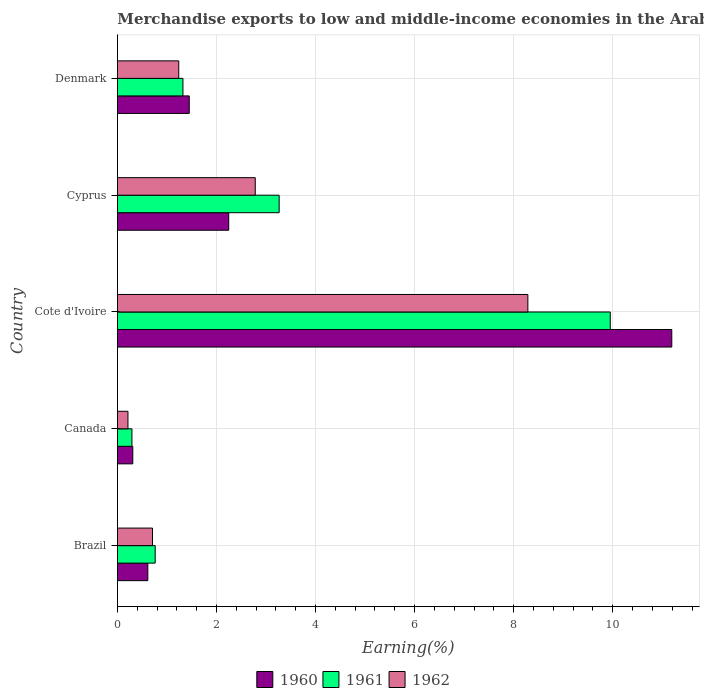How many groups of bars are there?
Give a very brief answer. 5. How many bars are there on the 3rd tick from the top?
Your response must be concise. 3. In how many cases, is the number of bars for a given country not equal to the number of legend labels?
Your response must be concise. 0. What is the percentage of amount earned from merchandise exports in 1960 in Canada?
Offer a very short reply. 0.31. Across all countries, what is the maximum percentage of amount earned from merchandise exports in 1962?
Give a very brief answer. 8.29. Across all countries, what is the minimum percentage of amount earned from merchandise exports in 1960?
Offer a very short reply. 0.31. In which country was the percentage of amount earned from merchandise exports in 1961 maximum?
Make the answer very short. Cote d'Ivoire. In which country was the percentage of amount earned from merchandise exports in 1962 minimum?
Provide a succinct answer. Canada. What is the total percentage of amount earned from merchandise exports in 1960 in the graph?
Keep it short and to the point. 15.81. What is the difference between the percentage of amount earned from merchandise exports in 1960 in Cote d'Ivoire and that in Cyprus?
Your answer should be compact. 8.94. What is the difference between the percentage of amount earned from merchandise exports in 1960 in Denmark and the percentage of amount earned from merchandise exports in 1961 in Canada?
Make the answer very short. 1.16. What is the average percentage of amount earned from merchandise exports in 1960 per country?
Offer a very short reply. 3.16. What is the difference between the percentage of amount earned from merchandise exports in 1961 and percentage of amount earned from merchandise exports in 1962 in Cyprus?
Provide a succinct answer. 0.48. In how many countries, is the percentage of amount earned from merchandise exports in 1962 greater than 6.8 %?
Provide a succinct answer. 1. What is the ratio of the percentage of amount earned from merchandise exports in 1962 in Cote d'Ivoire to that in Cyprus?
Your response must be concise. 2.98. Is the percentage of amount earned from merchandise exports in 1961 in Canada less than that in Denmark?
Ensure brevity in your answer.  Yes. What is the difference between the highest and the second highest percentage of amount earned from merchandise exports in 1960?
Give a very brief answer. 8.94. What is the difference between the highest and the lowest percentage of amount earned from merchandise exports in 1960?
Keep it short and to the point. 10.88. Is the sum of the percentage of amount earned from merchandise exports in 1962 in Canada and Cyprus greater than the maximum percentage of amount earned from merchandise exports in 1961 across all countries?
Your answer should be compact. No. What does the 3rd bar from the bottom in Brazil represents?
Make the answer very short. 1962. Is it the case that in every country, the sum of the percentage of amount earned from merchandise exports in 1962 and percentage of amount earned from merchandise exports in 1960 is greater than the percentage of amount earned from merchandise exports in 1961?
Keep it short and to the point. Yes. What is the difference between two consecutive major ticks on the X-axis?
Give a very brief answer. 2. What is the title of the graph?
Offer a terse response. Merchandise exports to low and middle-income economies in the Arab World. What is the label or title of the X-axis?
Keep it short and to the point. Earning(%). What is the Earning(%) of 1960 in Brazil?
Provide a succinct answer. 0.61. What is the Earning(%) of 1961 in Brazil?
Make the answer very short. 0.76. What is the Earning(%) of 1962 in Brazil?
Keep it short and to the point. 0.71. What is the Earning(%) in 1960 in Canada?
Provide a short and direct response. 0.31. What is the Earning(%) in 1961 in Canada?
Give a very brief answer. 0.29. What is the Earning(%) of 1962 in Canada?
Keep it short and to the point. 0.21. What is the Earning(%) in 1960 in Cote d'Ivoire?
Your response must be concise. 11.19. What is the Earning(%) of 1961 in Cote d'Ivoire?
Your answer should be compact. 9.95. What is the Earning(%) of 1962 in Cote d'Ivoire?
Give a very brief answer. 8.29. What is the Earning(%) in 1960 in Cyprus?
Your answer should be very brief. 2.25. What is the Earning(%) in 1961 in Cyprus?
Your response must be concise. 3.27. What is the Earning(%) of 1962 in Cyprus?
Keep it short and to the point. 2.78. What is the Earning(%) in 1960 in Denmark?
Give a very brief answer. 1.45. What is the Earning(%) of 1961 in Denmark?
Your answer should be compact. 1.32. What is the Earning(%) of 1962 in Denmark?
Provide a short and direct response. 1.24. Across all countries, what is the maximum Earning(%) of 1960?
Keep it short and to the point. 11.19. Across all countries, what is the maximum Earning(%) of 1961?
Your answer should be very brief. 9.95. Across all countries, what is the maximum Earning(%) in 1962?
Provide a short and direct response. 8.29. Across all countries, what is the minimum Earning(%) in 1960?
Provide a short and direct response. 0.31. Across all countries, what is the minimum Earning(%) of 1961?
Offer a terse response. 0.29. Across all countries, what is the minimum Earning(%) in 1962?
Your answer should be very brief. 0.21. What is the total Earning(%) in 1960 in the graph?
Provide a succinct answer. 15.81. What is the total Earning(%) in 1961 in the graph?
Your response must be concise. 15.59. What is the total Earning(%) of 1962 in the graph?
Offer a terse response. 13.23. What is the difference between the Earning(%) in 1960 in Brazil and that in Canada?
Your response must be concise. 0.3. What is the difference between the Earning(%) in 1961 in Brazil and that in Canada?
Ensure brevity in your answer.  0.47. What is the difference between the Earning(%) in 1962 in Brazil and that in Canada?
Offer a very short reply. 0.5. What is the difference between the Earning(%) of 1960 in Brazil and that in Cote d'Ivoire?
Your answer should be very brief. -10.58. What is the difference between the Earning(%) in 1961 in Brazil and that in Cote d'Ivoire?
Provide a succinct answer. -9.19. What is the difference between the Earning(%) in 1962 in Brazil and that in Cote d'Ivoire?
Provide a short and direct response. -7.58. What is the difference between the Earning(%) in 1960 in Brazil and that in Cyprus?
Offer a very short reply. -1.63. What is the difference between the Earning(%) in 1961 in Brazil and that in Cyprus?
Offer a terse response. -2.5. What is the difference between the Earning(%) in 1962 in Brazil and that in Cyprus?
Your answer should be very brief. -2.07. What is the difference between the Earning(%) in 1960 in Brazil and that in Denmark?
Offer a very short reply. -0.84. What is the difference between the Earning(%) in 1961 in Brazil and that in Denmark?
Your answer should be compact. -0.56. What is the difference between the Earning(%) in 1962 in Brazil and that in Denmark?
Provide a short and direct response. -0.53. What is the difference between the Earning(%) of 1960 in Canada and that in Cote d'Ivoire?
Give a very brief answer. -10.88. What is the difference between the Earning(%) of 1961 in Canada and that in Cote d'Ivoire?
Keep it short and to the point. -9.66. What is the difference between the Earning(%) of 1962 in Canada and that in Cote d'Ivoire?
Keep it short and to the point. -8.07. What is the difference between the Earning(%) in 1960 in Canada and that in Cyprus?
Ensure brevity in your answer.  -1.94. What is the difference between the Earning(%) in 1961 in Canada and that in Cyprus?
Keep it short and to the point. -2.97. What is the difference between the Earning(%) in 1962 in Canada and that in Cyprus?
Give a very brief answer. -2.57. What is the difference between the Earning(%) of 1960 in Canada and that in Denmark?
Ensure brevity in your answer.  -1.14. What is the difference between the Earning(%) of 1961 in Canada and that in Denmark?
Your response must be concise. -1.03. What is the difference between the Earning(%) in 1962 in Canada and that in Denmark?
Give a very brief answer. -1.03. What is the difference between the Earning(%) of 1960 in Cote d'Ivoire and that in Cyprus?
Offer a very short reply. 8.94. What is the difference between the Earning(%) in 1961 in Cote d'Ivoire and that in Cyprus?
Provide a short and direct response. 6.68. What is the difference between the Earning(%) of 1962 in Cote d'Ivoire and that in Cyprus?
Provide a succinct answer. 5.5. What is the difference between the Earning(%) of 1960 in Cote d'Ivoire and that in Denmark?
Make the answer very short. 9.74. What is the difference between the Earning(%) of 1961 in Cote d'Ivoire and that in Denmark?
Ensure brevity in your answer.  8.63. What is the difference between the Earning(%) in 1962 in Cote d'Ivoire and that in Denmark?
Provide a short and direct response. 7.05. What is the difference between the Earning(%) in 1960 in Cyprus and that in Denmark?
Provide a short and direct response. 0.8. What is the difference between the Earning(%) in 1961 in Cyprus and that in Denmark?
Make the answer very short. 1.94. What is the difference between the Earning(%) in 1962 in Cyprus and that in Denmark?
Ensure brevity in your answer.  1.54. What is the difference between the Earning(%) of 1960 in Brazil and the Earning(%) of 1961 in Canada?
Ensure brevity in your answer.  0.32. What is the difference between the Earning(%) of 1960 in Brazil and the Earning(%) of 1962 in Canada?
Ensure brevity in your answer.  0.4. What is the difference between the Earning(%) in 1961 in Brazil and the Earning(%) in 1962 in Canada?
Offer a very short reply. 0.55. What is the difference between the Earning(%) of 1960 in Brazil and the Earning(%) of 1961 in Cote d'Ivoire?
Provide a short and direct response. -9.34. What is the difference between the Earning(%) in 1960 in Brazil and the Earning(%) in 1962 in Cote d'Ivoire?
Your answer should be compact. -7.67. What is the difference between the Earning(%) in 1961 in Brazil and the Earning(%) in 1962 in Cote d'Ivoire?
Provide a short and direct response. -7.52. What is the difference between the Earning(%) in 1960 in Brazil and the Earning(%) in 1961 in Cyprus?
Offer a terse response. -2.65. What is the difference between the Earning(%) of 1960 in Brazil and the Earning(%) of 1962 in Cyprus?
Ensure brevity in your answer.  -2.17. What is the difference between the Earning(%) of 1961 in Brazil and the Earning(%) of 1962 in Cyprus?
Provide a short and direct response. -2.02. What is the difference between the Earning(%) in 1960 in Brazil and the Earning(%) in 1961 in Denmark?
Offer a terse response. -0.71. What is the difference between the Earning(%) in 1960 in Brazil and the Earning(%) in 1962 in Denmark?
Ensure brevity in your answer.  -0.62. What is the difference between the Earning(%) in 1961 in Brazil and the Earning(%) in 1962 in Denmark?
Keep it short and to the point. -0.48. What is the difference between the Earning(%) in 1960 in Canada and the Earning(%) in 1961 in Cote d'Ivoire?
Your response must be concise. -9.64. What is the difference between the Earning(%) in 1960 in Canada and the Earning(%) in 1962 in Cote d'Ivoire?
Provide a short and direct response. -7.98. What is the difference between the Earning(%) in 1961 in Canada and the Earning(%) in 1962 in Cote d'Ivoire?
Provide a succinct answer. -7.99. What is the difference between the Earning(%) in 1960 in Canada and the Earning(%) in 1961 in Cyprus?
Ensure brevity in your answer.  -2.95. What is the difference between the Earning(%) in 1960 in Canada and the Earning(%) in 1962 in Cyprus?
Give a very brief answer. -2.47. What is the difference between the Earning(%) in 1961 in Canada and the Earning(%) in 1962 in Cyprus?
Give a very brief answer. -2.49. What is the difference between the Earning(%) in 1960 in Canada and the Earning(%) in 1961 in Denmark?
Keep it short and to the point. -1.01. What is the difference between the Earning(%) of 1960 in Canada and the Earning(%) of 1962 in Denmark?
Make the answer very short. -0.93. What is the difference between the Earning(%) of 1961 in Canada and the Earning(%) of 1962 in Denmark?
Your answer should be very brief. -0.95. What is the difference between the Earning(%) in 1960 in Cote d'Ivoire and the Earning(%) in 1961 in Cyprus?
Your response must be concise. 7.93. What is the difference between the Earning(%) in 1960 in Cote d'Ivoire and the Earning(%) in 1962 in Cyprus?
Your answer should be very brief. 8.41. What is the difference between the Earning(%) in 1961 in Cote d'Ivoire and the Earning(%) in 1962 in Cyprus?
Your answer should be compact. 7.17. What is the difference between the Earning(%) of 1960 in Cote d'Ivoire and the Earning(%) of 1961 in Denmark?
Provide a succinct answer. 9.87. What is the difference between the Earning(%) in 1960 in Cote d'Ivoire and the Earning(%) in 1962 in Denmark?
Your response must be concise. 9.95. What is the difference between the Earning(%) of 1961 in Cote d'Ivoire and the Earning(%) of 1962 in Denmark?
Your answer should be very brief. 8.71. What is the difference between the Earning(%) in 1960 in Cyprus and the Earning(%) in 1961 in Denmark?
Your answer should be compact. 0.92. What is the difference between the Earning(%) in 1960 in Cyprus and the Earning(%) in 1962 in Denmark?
Provide a succinct answer. 1.01. What is the difference between the Earning(%) of 1961 in Cyprus and the Earning(%) of 1962 in Denmark?
Your answer should be compact. 2.03. What is the average Earning(%) of 1960 per country?
Make the answer very short. 3.16. What is the average Earning(%) of 1961 per country?
Your response must be concise. 3.12. What is the average Earning(%) of 1962 per country?
Offer a terse response. 2.65. What is the difference between the Earning(%) in 1960 and Earning(%) in 1961 in Brazil?
Provide a succinct answer. -0.15. What is the difference between the Earning(%) in 1960 and Earning(%) in 1962 in Brazil?
Your answer should be very brief. -0.09. What is the difference between the Earning(%) of 1961 and Earning(%) of 1962 in Brazil?
Give a very brief answer. 0.05. What is the difference between the Earning(%) in 1960 and Earning(%) in 1961 in Canada?
Your answer should be very brief. 0.02. What is the difference between the Earning(%) in 1960 and Earning(%) in 1962 in Canada?
Your answer should be very brief. 0.1. What is the difference between the Earning(%) of 1961 and Earning(%) of 1962 in Canada?
Your response must be concise. 0.08. What is the difference between the Earning(%) in 1960 and Earning(%) in 1961 in Cote d'Ivoire?
Offer a terse response. 1.24. What is the difference between the Earning(%) in 1960 and Earning(%) in 1962 in Cote d'Ivoire?
Provide a short and direct response. 2.91. What is the difference between the Earning(%) in 1961 and Earning(%) in 1962 in Cote d'Ivoire?
Give a very brief answer. 1.66. What is the difference between the Earning(%) in 1960 and Earning(%) in 1961 in Cyprus?
Your answer should be compact. -1.02. What is the difference between the Earning(%) of 1960 and Earning(%) of 1962 in Cyprus?
Your answer should be compact. -0.54. What is the difference between the Earning(%) of 1961 and Earning(%) of 1962 in Cyprus?
Offer a very short reply. 0.48. What is the difference between the Earning(%) in 1960 and Earning(%) in 1961 in Denmark?
Provide a succinct answer. 0.13. What is the difference between the Earning(%) of 1960 and Earning(%) of 1962 in Denmark?
Your answer should be very brief. 0.21. What is the difference between the Earning(%) in 1961 and Earning(%) in 1962 in Denmark?
Keep it short and to the point. 0.08. What is the ratio of the Earning(%) in 1960 in Brazil to that in Canada?
Provide a short and direct response. 1.98. What is the ratio of the Earning(%) in 1961 in Brazil to that in Canada?
Offer a terse response. 2.6. What is the ratio of the Earning(%) in 1962 in Brazil to that in Canada?
Provide a short and direct response. 3.33. What is the ratio of the Earning(%) of 1960 in Brazil to that in Cote d'Ivoire?
Make the answer very short. 0.05. What is the ratio of the Earning(%) in 1961 in Brazil to that in Cote d'Ivoire?
Make the answer very short. 0.08. What is the ratio of the Earning(%) in 1962 in Brazil to that in Cote d'Ivoire?
Your response must be concise. 0.09. What is the ratio of the Earning(%) in 1960 in Brazil to that in Cyprus?
Provide a short and direct response. 0.27. What is the ratio of the Earning(%) in 1961 in Brazil to that in Cyprus?
Provide a succinct answer. 0.23. What is the ratio of the Earning(%) in 1962 in Brazil to that in Cyprus?
Make the answer very short. 0.25. What is the ratio of the Earning(%) in 1960 in Brazil to that in Denmark?
Offer a very short reply. 0.42. What is the ratio of the Earning(%) in 1961 in Brazil to that in Denmark?
Give a very brief answer. 0.58. What is the ratio of the Earning(%) of 1962 in Brazil to that in Denmark?
Provide a succinct answer. 0.57. What is the ratio of the Earning(%) of 1960 in Canada to that in Cote d'Ivoire?
Make the answer very short. 0.03. What is the ratio of the Earning(%) of 1961 in Canada to that in Cote d'Ivoire?
Ensure brevity in your answer.  0.03. What is the ratio of the Earning(%) in 1962 in Canada to that in Cote d'Ivoire?
Your answer should be very brief. 0.03. What is the ratio of the Earning(%) in 1960 in Canada to that in Cyprus?
Your answer should be compact. 0.14. What is the ratio of the Earning(%) in 1961 in Canada to that in Cyprus?
Your answer should be very brief. 0.09. What is the ratio of the Earning(%) of 1962 in Canada to that in Cyprus?
Provide a short and direct response. 0.08. What is the ratio of the Earning(%) in 1960 in Canada to that in Denmark?
Provide a succinct answer. 0.21. What is the ratio of the Earning(%) of 1961 in Canada to that in Denmark?
Your answer should be compact. 0.22. What is the ratio of the Earning(%) of 1962 in Canada to that in Denmark?
Your response must be concise. 0.17. What is the ratio of the Earning(%) of 1960 in Cote d'Ivoire to that in Cyprus?
Your response must be concise. 4.98. What is the ratio of the Earning(%) of 1961 in Cote d'Ivoire to that in Cyprus?
Give a very brief answer. 3.05. What is the ratio of the Earning(%) in 1962 in Cote d'Ivoire to that in Cyprus?
Your answer should be compact. 2.98. What is the ratio of the Earning(%) in 1960 in Cote d'Ivoire to that in Denmark?
Offer a terse response. 7.72. What is the ratio of the Earning(%) in 1961 in Cote d'Ivoire to that in Denmark?
Offer a very short reply. 7.52. What is the ratio of the Earning(%) of 1962 in Cote d'Ivoire to that in Denmark?
Ensure brevity in your answer.  6.69. What is the ratio of the Earning(%) in 1960 in Cyprus to that in Denmark?
Offer a terse response. 1.55. What is the ratio of the Earning(%) of 1961 in Cyprus to that in Denmark?
Offer a very short reply. 2.47. What is the ratio of the Earning(%) of 1962 in Cyprus to that in Denmark?
Give a very brief answer. 2.25. What is the difference between the highest and the second highest Earning(%) of 1960?
Give a very brief answer. 8.94. What is the difference between the highest and the second highest Earning(%) of 1961?
Give a very brief answer. 6.68. What is the difference between the highest and the second highest Earning(%) of 1962?
Give a very brief answer. 5.5. What is the difference between the highest and the lowest Earning(%) in 1960?
Keep it short and to the point. 10.88. What is the difference between the highest and the lowest Earning(%) in 1961?
Ensure brevity in your answer.  9.66. What is the difference between the highest and the lowest Earning(%) in 1962?
Offer a terse response. 8.07. 